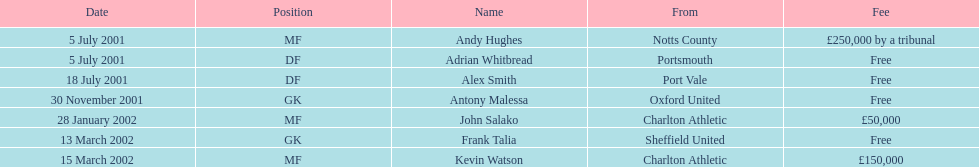What are all of the names? Andy Hughes, Adrian Whitbread, Alex Smith, Antony Malessa, John Salako, Frank Talia, Kevin Watson. What was the fee for each person? £250,000 by a tribunal, Free, Free, Free, £50,000, Free, £150,000. And who had the highest fee? Andy Hughes. Would you be able to parse every entry in this table? {'header': ['Date', 'Position', 'Name', 'From', 'Fee'], 'rows': [['5 July 2001', 'MF', 'Andy Hughes', 'Notts County', '£250,000 by a tribunal'], ['5 July 2001', 'DF', 'Adrian Whitbread', 'Portsmouth', 'Free'], ['18 July 2001', 'DF', 'Alex Smith', 'Port Vale', 'Free'], ['30 November 2001', 'GK', 'Antony Malessa', 'Oxford United', 'Free'], ['28 January 2002', 'MF', 'John Salako', 'Charlton Athletic', '£50,000'], ['13 March 2002', 'GK', 'Frank Talia', 'Sheffield United', 'Free'], ['15 March 2002', 'MF', 'Kevin Watson', 'Charlton Athletic', '£150,000']]} 